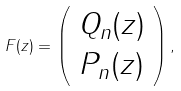Convert formula to latex. <formula><loc_0><loc_0><loc_500><loc_500>F ( z ) = \left ( \begin{array} { c } Q _ { n } ( z ) \\ P _ { n } ( z ) \end{array} \right ) ,</formula> 